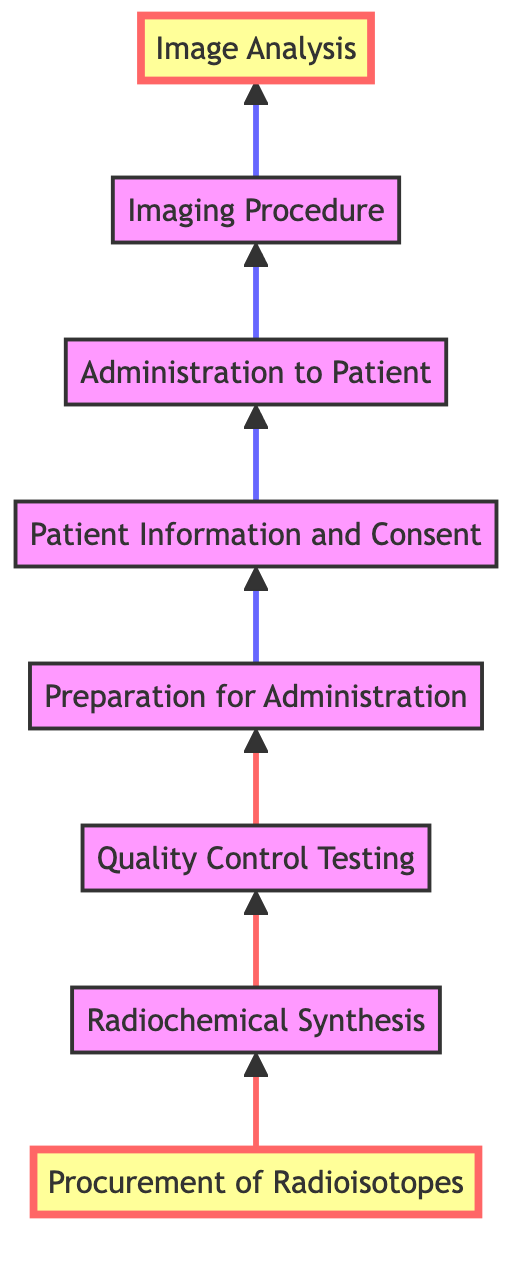What is the first step in the flow chart? The first step is the starting point of the flow chart, which is the node labeled "Procurement of Radioisotopes."
Answer: Procurement of Radioisotopes How many steps are in the flow chart? By counting each labeled step in the flow chart from "Procurement of Radioisotopes" to "Image Analysis," there are a total of eight steps.
Answer: 8 What is the last step in the flow chart? The last step in the flow chart is indicated by the final node, which is "Image Analysis."
Answer: Image Analysis Which step comes immediately after "Quality Control Testing"? The flow chart shows that "Preparation for Administration" follows directly after "Quality Control Testing," indicating a sequential relationship.
Answer: Preparation for Administration What step is labeled directly above "Imaging Procedure"? In the diagram, "Administration to Patient" is the step that is positioned directly above "Imaging Procedure" in the flow from bottom to top.
Answer: Administration to Patient How many arrows point to the step "Administration to Patient"? There is one arrow pointing to "Administration to Patient," as it is the outcome of the previous step "Patient Information and Consent."
Answer: 1 What steps involve patient interactions? The steps "Patient Information and Consent" and "Administration to Patient" both involve direct interactions with the patient as part of the process.
Answer: Patient Information and Consent; Administration to Patient Which two steps highlight the importance of safety in the process? The steps "Quality Control Testing" and "Patient Information and Consent" emphasize safety, with the former ensuring the radiopharmaceutical's quality and the latter informing patients about risks.
Answer: Quality Control Testing; Patient Information and Consent What is the main purpose of the "Imaging Procedure"? The main purpose of the "Imaging Procedure" is to perform diagnostic imaging using the administered radiopharmaceutical during a scan.
Answer: Diagnostic imaging What step does "Radiochemical Synthesis" lead to? "Radiochemical Synthesis" leads directly to "Quality Control Testing," following the logical sequence outlined in the flow chart.
Answer: Quality Control Testing 